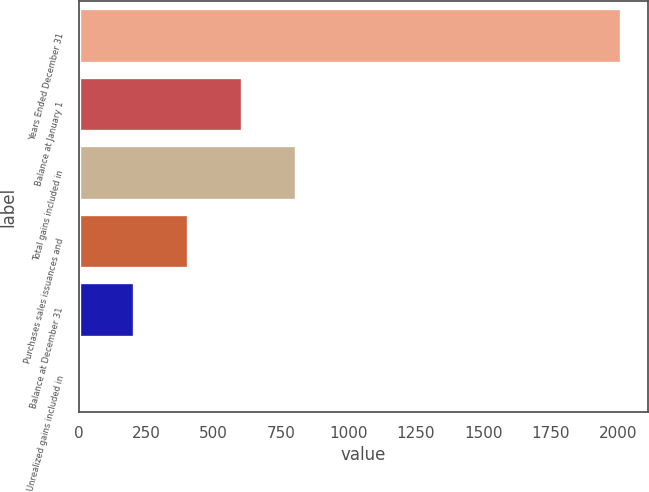Convert chart. <chart><loc_0><loc_0><loc_500><loc_500><bar_chart><fcel>Years Ended December 31<fcel>Balance at January 1<fcel>Total gains included in<fcel>Purchases sales issuances and<fcel>Balance at December 31<fcel>Unrealized gains included in<nl><fcel>2009<fcel>606.9<fcel>807.2<fcel>406.6<fcel>206.3<fcel>6<nl></chart> 